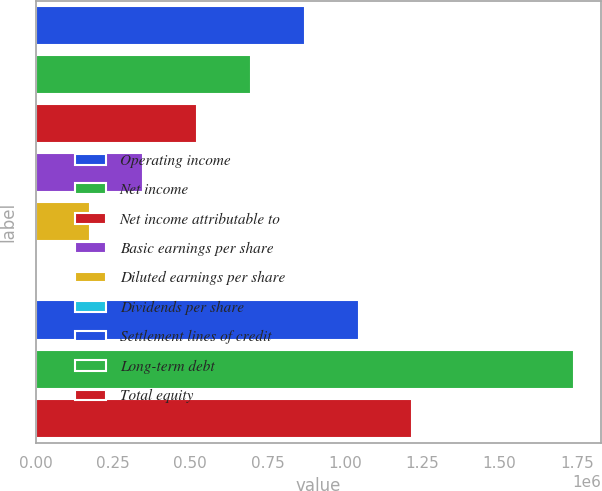Convert chart to OTSL. <chart><loc_0><loc_0><loc_500><loc_500><bar_chart><fcel>Operating income<fcel>Net income<fcel>Net income attributable to<fcel>Basic earnings per share<fcel>Diluted earnings per share<fcel>Dividends per share<fcel>Settlement lines of credit<fcel>Long-term debt<fcel>Total equity<nl><fcel>870034<fcel>696027<fcel>522020<fcel>348013<fcel>174007<fcel>0.04<fcel>1.04404e+06<fcel>1.74007e+06<fcel>1.21805e+06<nl></chart> 